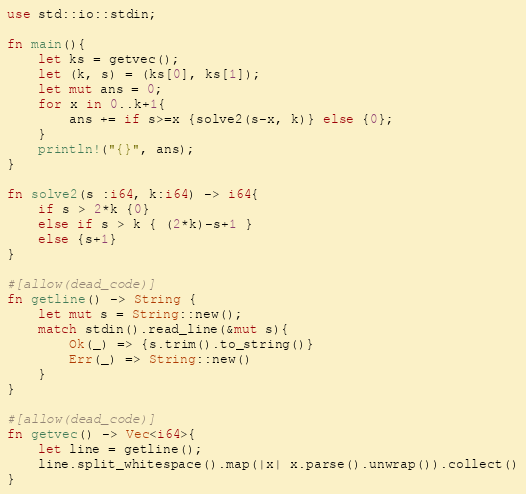<code> <loc_0><loc_0><loc_500><loc_500><_Rust_>use std::io::stdin;

fn main(){
    let ks = getvec();
    let (k, s) = (ks[0], ks[1]);
    let mut ans = 0;
    for x in 0..k+1{
        ans += if s>=x {solve2(s-x, k)} else {0};
    }
    println!("{}", ans);
}

fn solve2(s :i64, k:i64) -> i64{
    if s > 2*k {0}
    else if s > k { (2*k)-s+1 }
    else {s+1}
}

#[allow(dead_code)]
fn getline() -> String {
    let mut s = String::new();
    match stdin().read_line(&mut s){
        Ok(_) => {s.trim().to_string()}
        Err(_) => String::new()
    }
}

#[allow(dead_code)]
fn getvec() -> Vec<i64>{
    let line = getline();
    line.split_whitespace().map(|x| x.parse().unwrap()).collect()
}</code> 